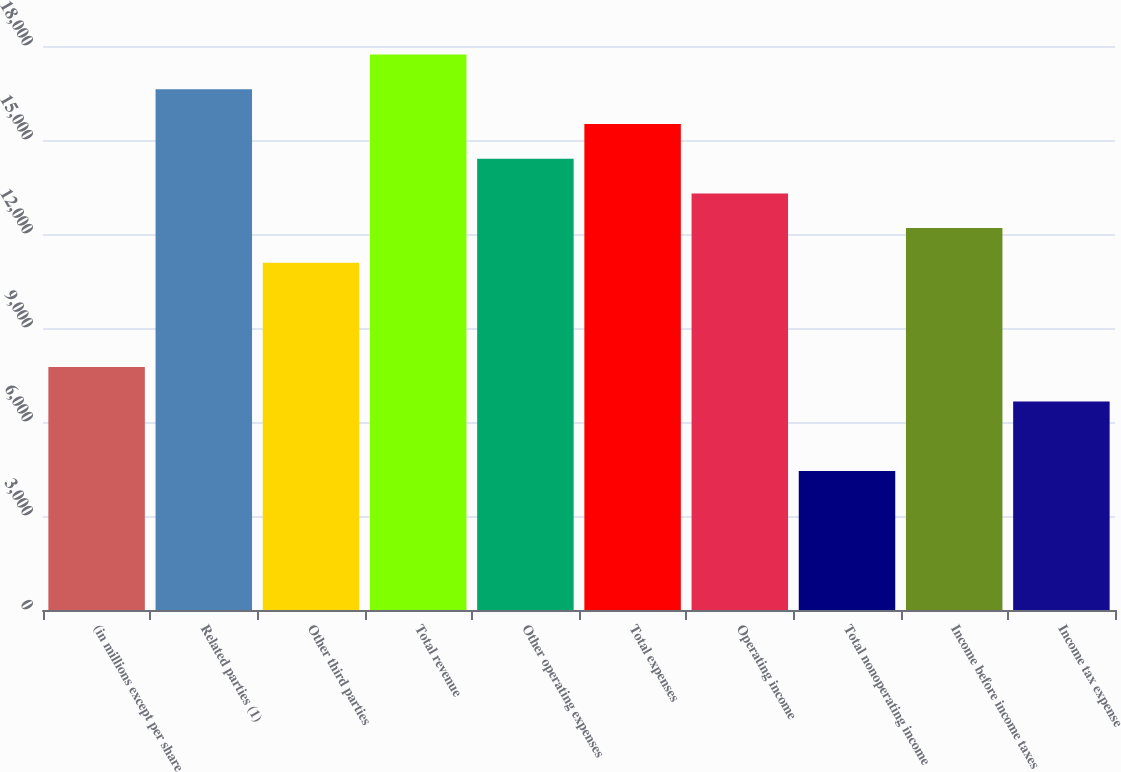Convert chart. <chart><loc_0><loc_0><loc_500><loc_500><bar_chart><fcel>(in millions except per share<fcel>Related parties (1)<fcel>Other third parties<fcel>Total revenue<fcel>Other operating expenses<fcel>Total expenses<fcel>Operating income<fcel>Total nonoperating income<fcel>Income before income taxes<fcel>Income tax expense<nl><fcel>7759.03<fcel>16617.7<fcel>11081<fcel>17725<fcel>14403<fcel>15510.3<fcel>13295.7<fcel>4437.04<fcel>12188.4<fcel>6651.7<nl></chart> 